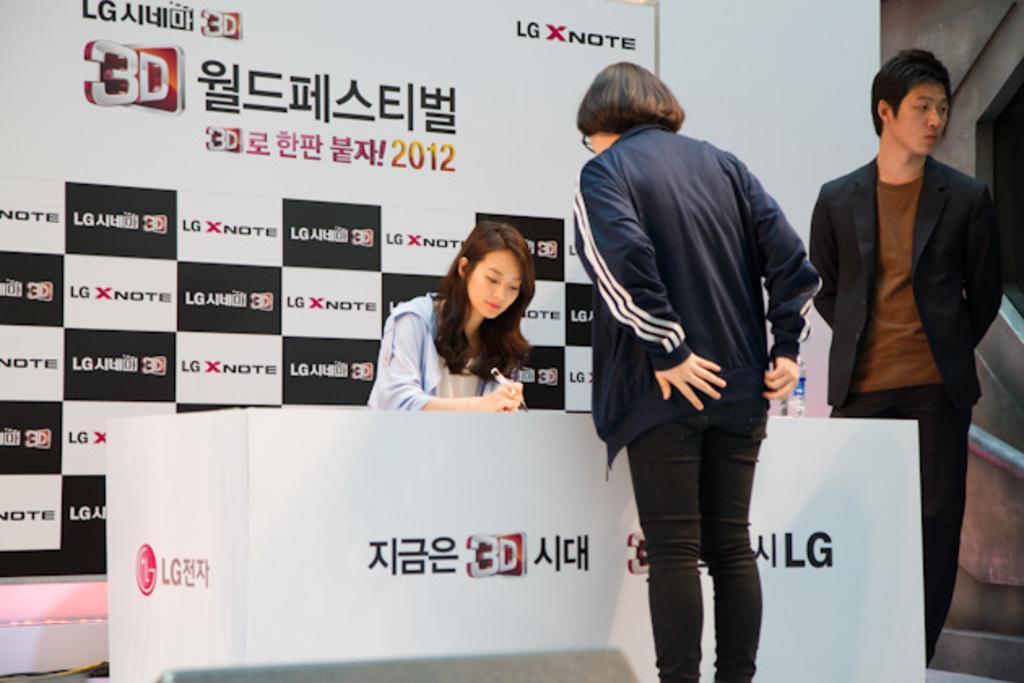Please provide a concise description of this image. This picture is taken inside the room. In this image, on the right side, we can see a man standing. In the middle of the image, we can see a woman standing in front of the table, on that table, we can see a water bottle. On the right side, we can see a metal rod, we can also see a woman standing in front of the table. In the background, we can see a hoarding and a wall which is in white color. 